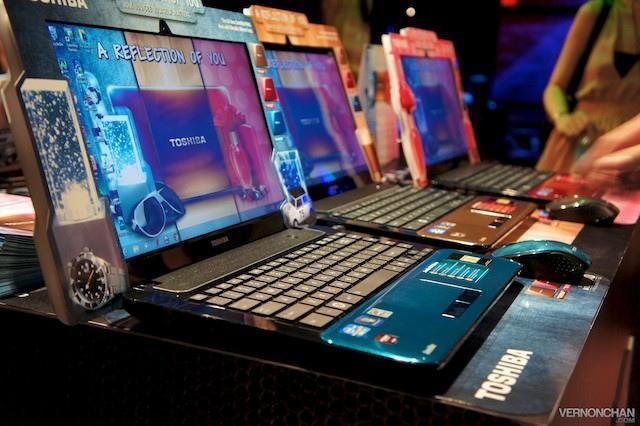How many computers are there?
Give a very brief answer. 3. How many laptops are there?
Give a very brief answer. 3. 